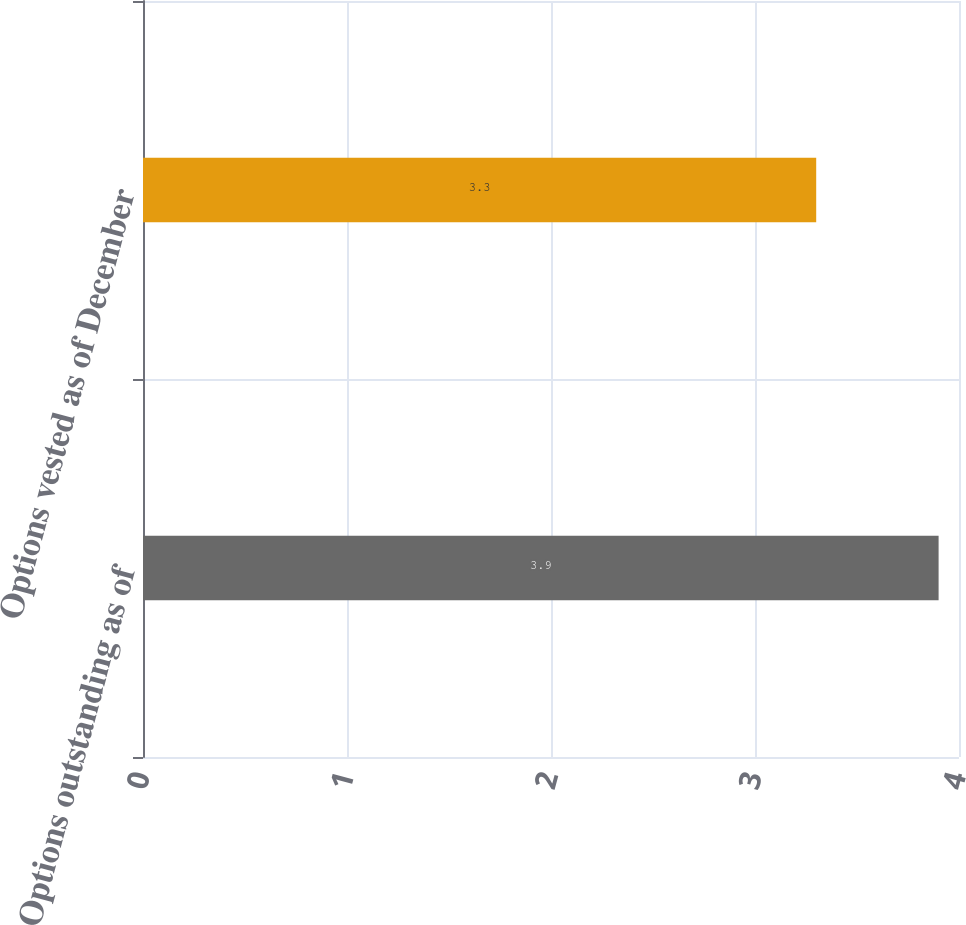Convert chart. <chart><loc_0><loc_0><loc_500><loc_500><bar_chart><fcel>Options outstanding as of<fcel>Options vested as of December<nl><fcel>3.9<fcel>3.3<nl></chart> 